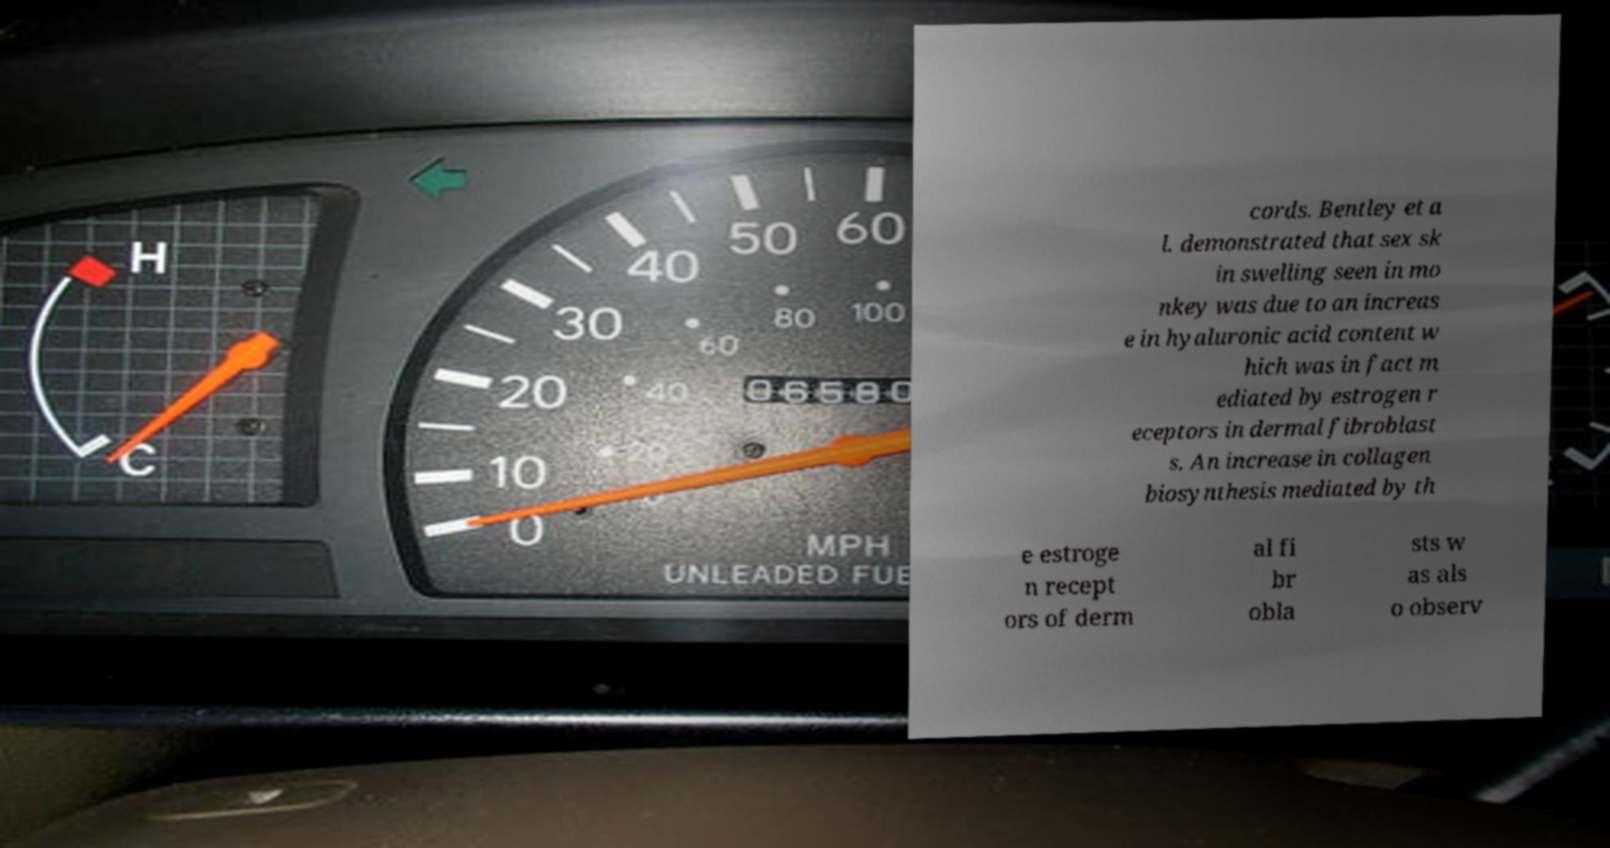I need the written content from this picture converted into text. Can you do that? cords. Bentley et a l. demonstrated that sex sk in swelling seen in mo nkey was due to an increas e in hyaluronic acid content w hich was in fact m ediated by estrogen r eceptors in dermal fibroblast s. An increase in collagen biosynthesis mediated by th e estroge n recept ors of derm al fi br obla sts w as als o observ 